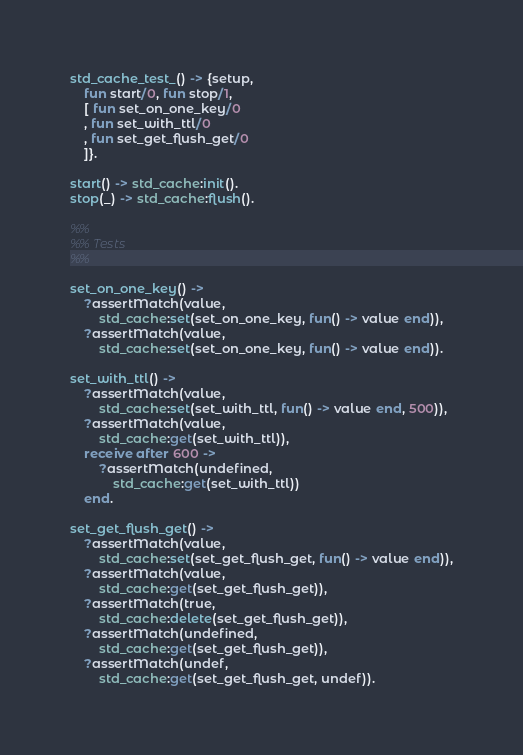<code> <loc_0><loc_0><loc_500><loc_500><_Erlang_>std_cache_test_() -> {setup,
    fun start/0, fun stop/1,
    [ fun set_on_one_key/0
    , fun set_with_ttl/0
    , fun set_get_flush_get/0
    ]}.

start() -> std_cache:init().
stop(_) -> std_cache:flush().

%%
%% Tests
%%

set_on_one_key() ->
    ?assertMatch(value,
        std_cache:set(set_on_one_key, fun() -> value end)),
    ?assertMatch(value,
        std_cache:set(set_on_one_key, fun() -> value end)).

set_with_ttl() ->
    ?assertMatch(value,
        std_cache:set(set_with_ttl, fun() -> value end, 500)),
    ?assertMatch(value,
        std_cache:get(set_with_ttl)),
    receive after 600 ->
        ?assertMatch(undefined,
            std_cache:get(set_with_ttl))
    end.

set_get_flush_get() ->
    ?assertMatch(value,
        std_cache:set(set_get_flush_get, fun() -> value end)),
    ?assertMatch(value,
        std_cache:get(set_get_flush_get)),
    ?assertMatch(true,
        std_cache:delete(set_get_flush_get)),
    ?assertMatch(undefined,
        std_cache:get(set_get_flush_get)),
    ?assertMatch(undef,
        std_cache:get(set_get_flush_get, undef)).
</code> 